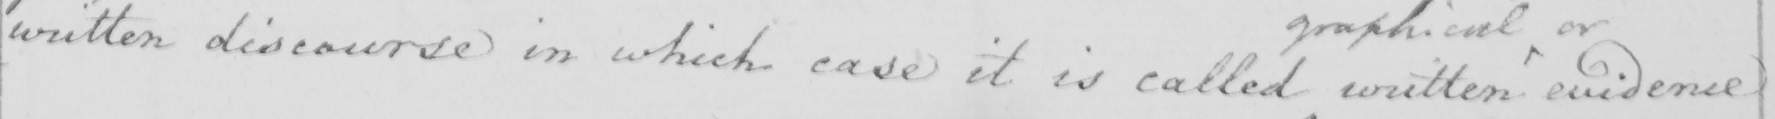Transcribe the text shown in this historical manuscript line. written discourse in which case it is called written evidence 